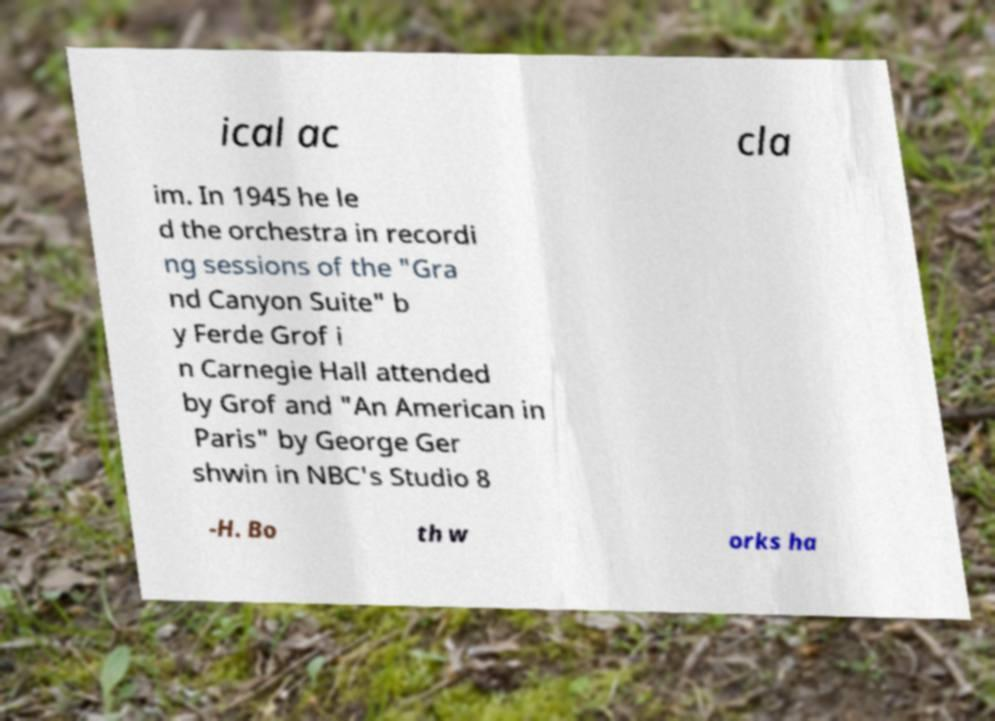What messages or text are displayed in this image? I need them in a readable, typed format. ical ac cla im. In 1945 he le d the orchestra in recordi ng sessions of the "Gra nd Canyon Suite" b y Ferde Grof i n Carnegie Hall attended by Grof and "An American in Paris" by George Ger shwin in NBC's Studio 8 -H. Bo th w orks ha 